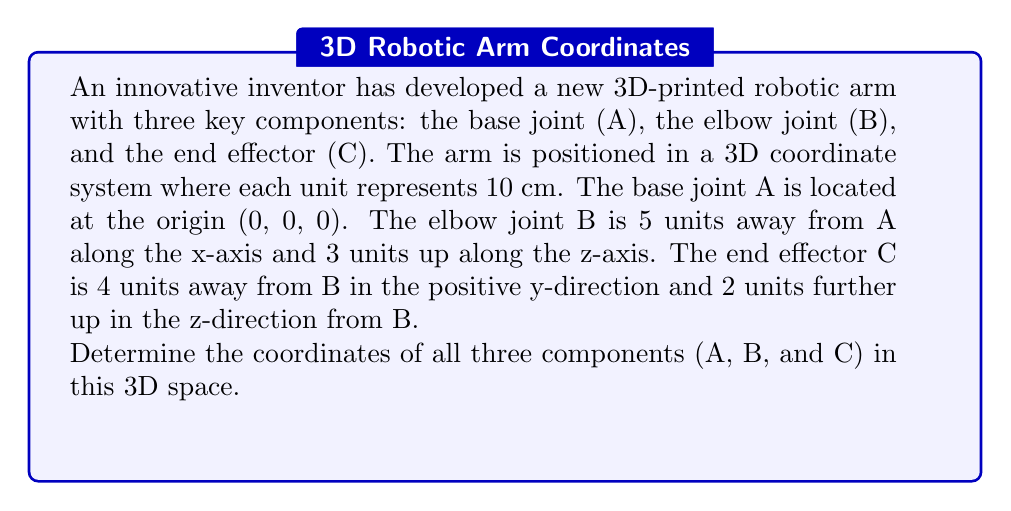Solve this math problem. Let's approach this step-by-step:

1) Component A (Base Joint):
   - Given: A is located at the origin.
   - Coordinates of A: (0, 0, 0)

2) Component B (Elbow Joint):
   - Given: B is 5 units away from A along the x-axis and 3 units up along the z-axis.
   - x-coordinate: 0 + 5 = 5
   - y-coordinate: 0 (no movement along y-axis)
   - z-coordinate: 0 + 3 = 3
   - Coordinates of B: (5, 0, 3)

3) Component C (End Effector):
   - Given: C is 4 units away from B in the positive y-direction and 2 units further up in the z-direction from B.
   - x-coordinate: Same as B = 5
   - y-coordinate: 0 + 4 = 4 (4 units in positive y-direction from B)
   - z-coordinate: 3 + 2 = 5 (2 units further up from B's z-coordinate)
   - Coordinates of C: (5, 4, 5)

Therefore, the coordinates of the three components are:
A: (0, 0, 0)
B: (5, 0, 3)
C: (5, 4, 5)
Answer: A(0,0,0), B(5,0,3), C(5,4,5) 